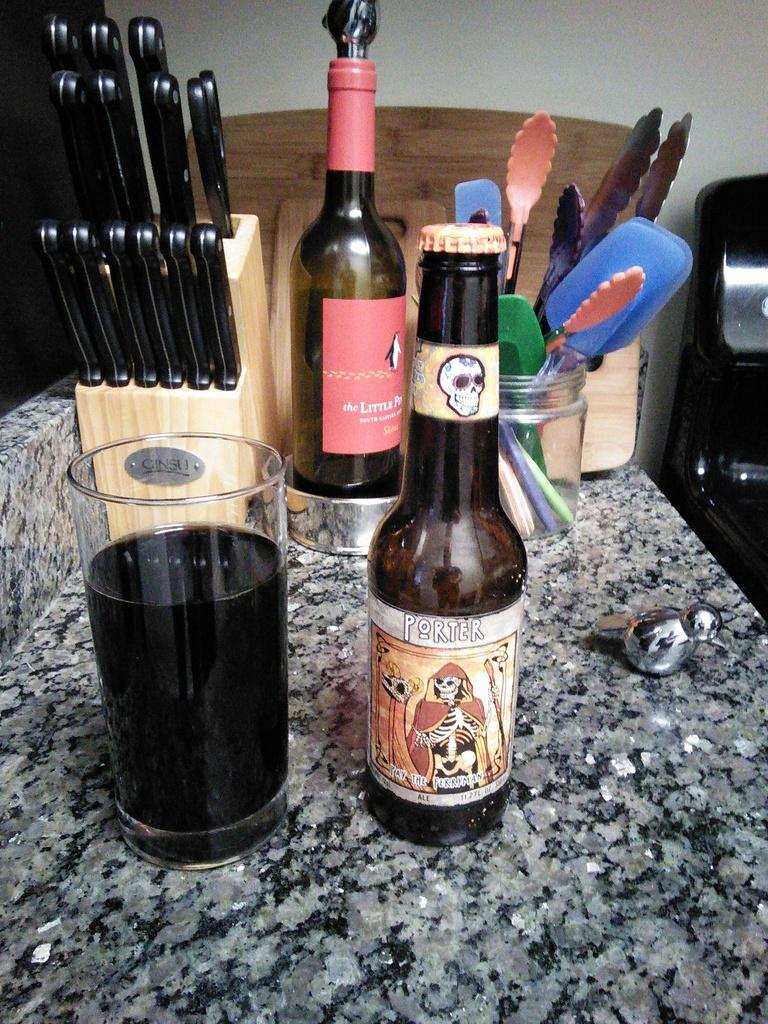<image>
Create a compact narrative representing the image presented. bottle of porter ale next to a full glass with a set of knives, bottle of win, and kitchen utensils on a stone countertop 